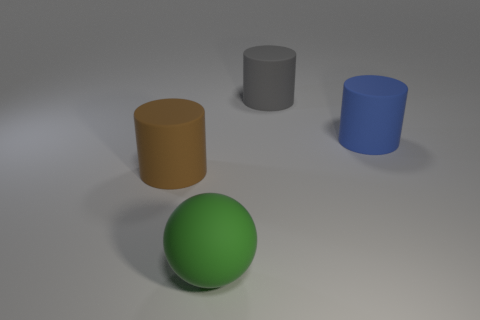How many big cylinders are behind the blue rubber cylinder and on the left side of the green rubber thing?
Your response must be concise. 0. What is the green sphere made of?
Offer a terse response. Rubber. How many things are either red objects or matte spheres?
Your answer should be very brief. 1. There is a rubber cylinder that is left of the big green sphere; does it have the same size as the matte cylinder right of the large gray thing?
Ensure brevity in your answer.  Yes. What number of other objects are the same size as the blue cylinder?
Make the answer very short. 3. How many things are cylinders that are behind the blue cylinder or cylinders behind the blue object?
Ensure brevity in your answer.  1. Do the brown thing and the large thing behind the blue rubber object have the same material?
Your response must be concise. Yes. What number of other things are the same shape as the large gray object?
Offer a very short reply. 2. Are there an equal number of brown cylinders that are on the right side of the blue matte cylinder and cyan metallic cubes?
Your answer should be compact. Yes. Does the object that is in front of the big brown rubber thing have the same material as the big thing that is behind the big blue cylinder?
Keep it short and to the point. Yes. 